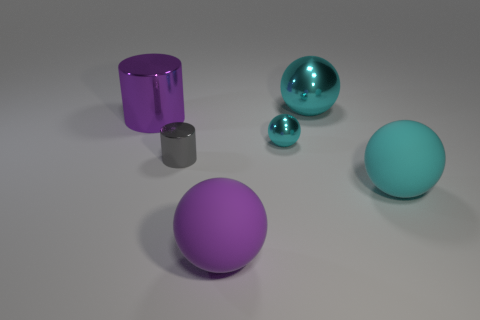How many cyan spheres must be subtracted to get 1 cyan spheres? 2 Subtract all blue cubes. How many cyan balls are left? 3 Subtract 1 balls. How many balls are left? 3 Add 2 rubber things. How many objects exist? 8 Subtract all spheres. How many objects are left? 2 Subtract all small brown cylinders. Subtract all large purple matte objects. How many objects are left? 5 Add 6 small gray objects. How many small gray objects are left? 7 Add 1 green matte blocks. How many green matte blocks exist? 1 Subtract 0 blue balls. How many objects are left? 6 